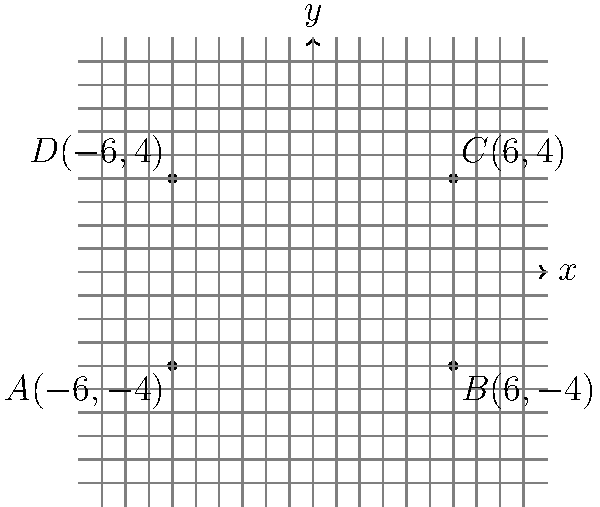As a former player of the Somalia national under-17 football team, you're familiar with standard football field dimensions. Given a rectangular football field with vertices $A(-6,-4)$, $B(6,-4)$, $C(6,4)$, and $D(-6,4)$ on a coordinate system where each unit represents 10 meters, calculate the area of the field in square meters. To calculate the area of the rectangular football field, we need to follow these steps:

1) First, let's identify the length and width of the field:
   - Length: distance between points A and B (or D and C)
   - Width: distance between points A and D (or B and C)

2) Calculate the length:
   $length = |x_B - x_A| = |6 - (-6)| = |12| = 12$ units

3) Calculate the width:
   $width = |y_D - y_A| = |4 - (-4)| = |8| = 8$ units

4) Calculate the area in square units:
   $area = length \times width = 12 \times 8 = 96$ square units

5) Convert to square meters:
   Since each unit represents 10 meters, we need to multiply our result by $10^2 = 100$:
   $area_{in~m^2} = 96 \times 100 = 9600$ square meters

Therefore, the area of the football field is 9600 square meters.
Answer: 9600 $m^2$ 